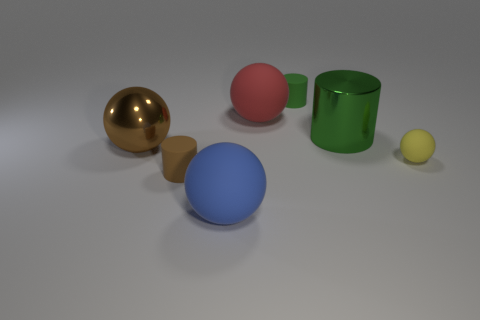Do the yellow ball and the big brown thing have the same material? no 